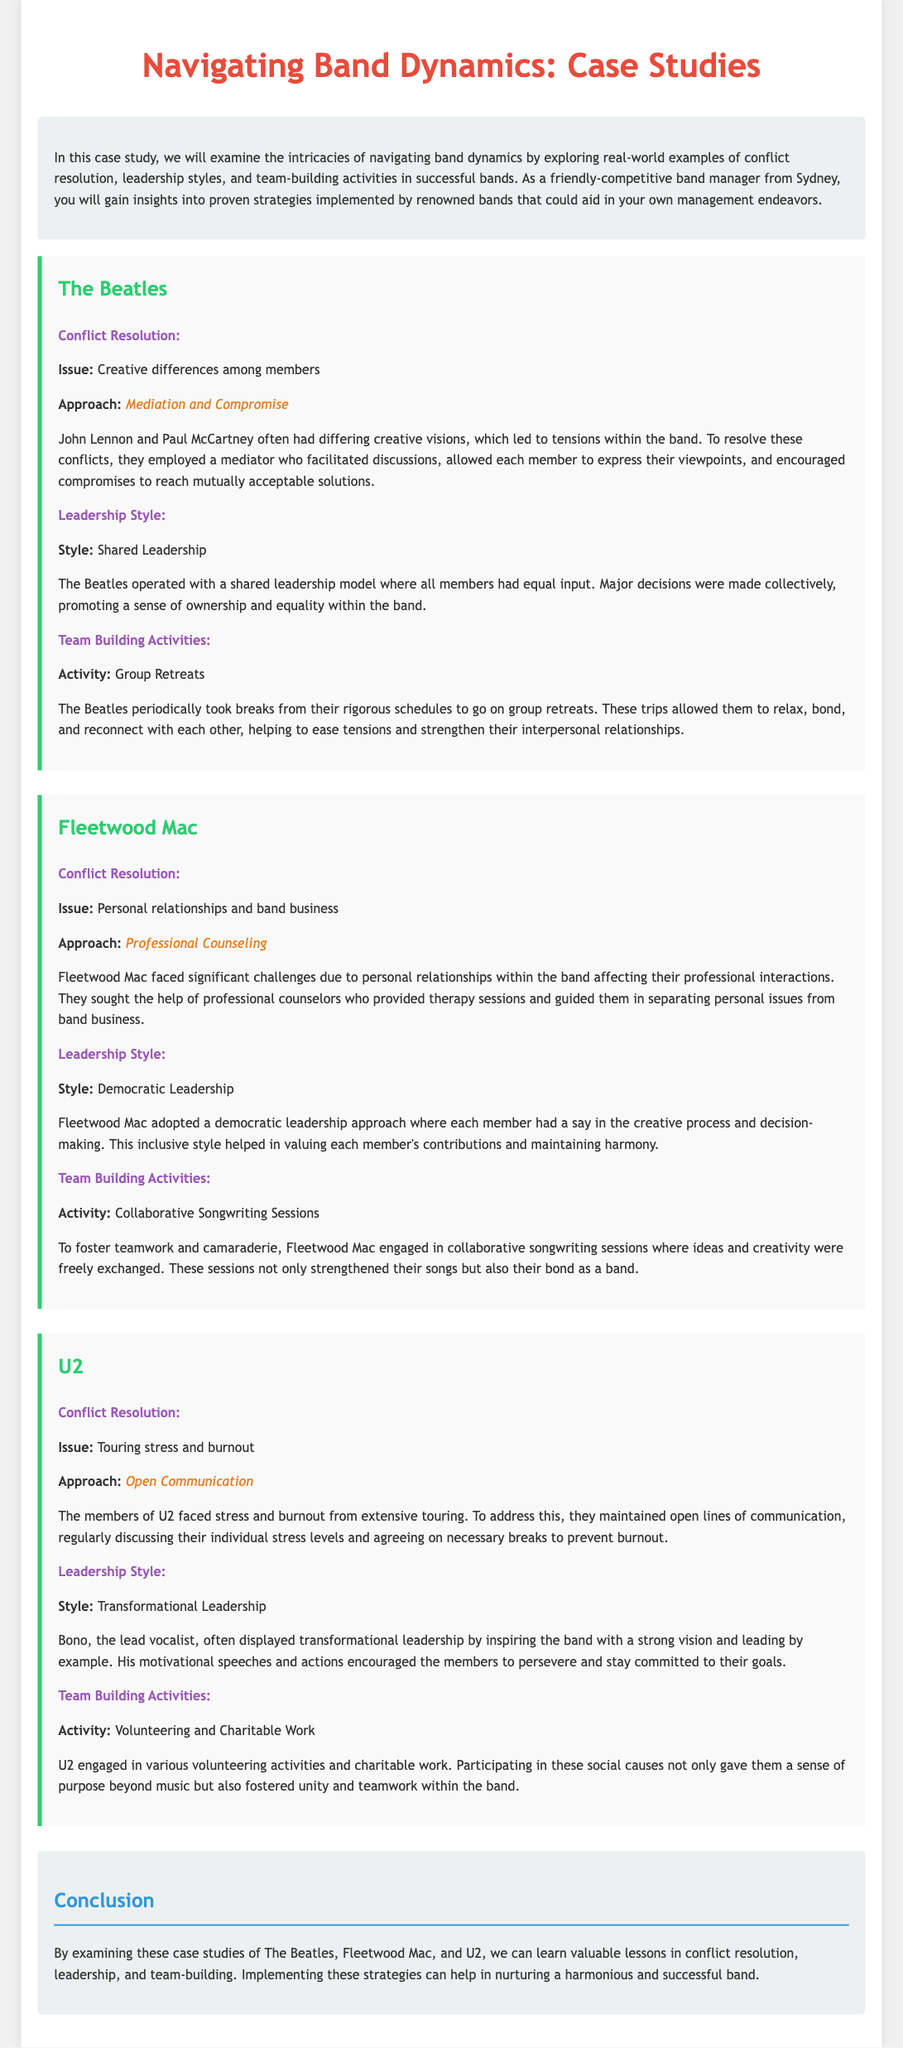What was the conflict issue in The Beatles? The document states that The Beatles faced creative differences among members, which led to tensions within the band.
Answer: Creative differences What approach did Fleetwood Mac use for conflict resolution? According to the case study, Fleetwood Mac sought the help of professional counselors for conflict resolution.
Answer: Professional Counseling Which leadership style did U2 primarily adopt? The case study highlights U2's leadership style as transformational leadership, particularly displayed by Bono.
Answer: Transformational Leadership What team-building activity did Fleetwood Mac engage in? The document mentions that Fleetwood Mac participated in collaborative songwriting sessions as a team-building activity.
Answer: Collaborative Songwriting Sessions What type of communication did U2 use to address stress? The members of U2 utilized open communication to discuss their individual stress levels.
Answer: Open Communication What is a common team-building activity mentioned for The Beatles? The case study points out that The Beatles went on group retreats as a team-building activity.
Answer: Group Retreats Which band adopted a democratic leadership style? The document clearly states that Fleetwood Mac adopted a democratic leadership style.
Answer: Fleetwood Mac What was a significant issue faced by U2? The case study notes that U2 faced issues related to touring stress and burnout.
Answer: Touring stress and burnout What was the conclusion of the case studies regarding band dynamics? The conclusion discusses the valuable lessons learned in conflict resolution, leadership, and team-building from the bands examined.
Answer: Valuable lessons in conflict resolution, leadership, and team-building 